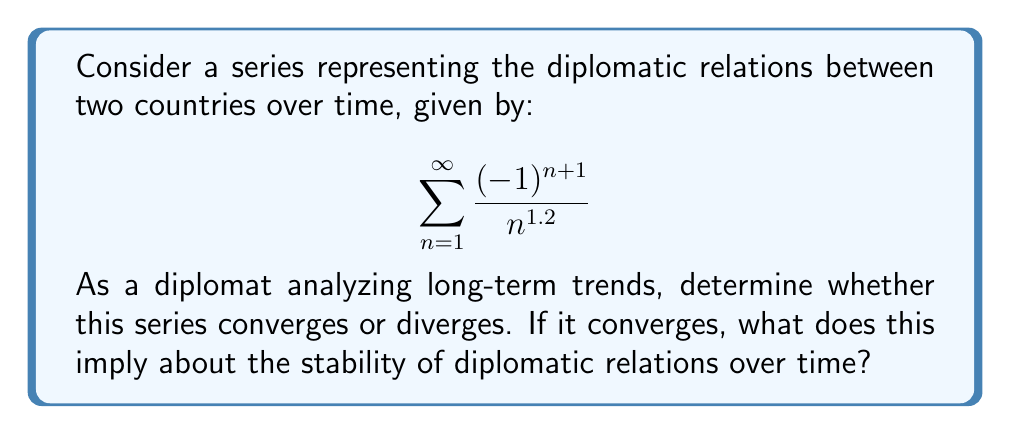Could you help me with this problem? To analyze the convergence of this series, we can use the alternating series test:

1) First, let's define $a_n = \frac{1}{n^{1.2}}$

2) We need to check if $a_n$ is decreasing and approaches 0 as $n$ approaches infinity:

   $\lim_{n \to \infty} a_n = \lim_{n \to \infty} \frac{1}{n^{1.2}} = 0$

3) To show $a_n$ is decreasing, we can prove $a_n > a_{n+1}$ for all $n$:

   $\frac{1}{n^{1.2}} > \frac{1}{(n+1)^{1.2}}$
   
   This is true for all $n \geq 1$ because $n < n+1$.

4) The alternating series test states that if $a_n$ is decreasing and approaches 0, then the series $\sum_{n=1}^{\infty} (-1)^{n+1}a_n$ converges.

5) We can also note that this series is absolutely convergent because:

   $\sum_{n=1}^{\infty} \frac{1}{n^{1.2}}$

   is a p-series with $p > 1$, which converges.

In the context of diplomatic relations, convergence implies that the fluctuations in relations between the two countries become smaller over time, eventually stabilizing around a particular value. This suggests that while there may be short-term variations, the long-term diplomatic relationship tends towards a stable equilibrium.
Answer: The series converges by the alternating series test and is also absolutely convergent. This implies long-term stability in diplomatic relations with decreasing fluctuations over time. 